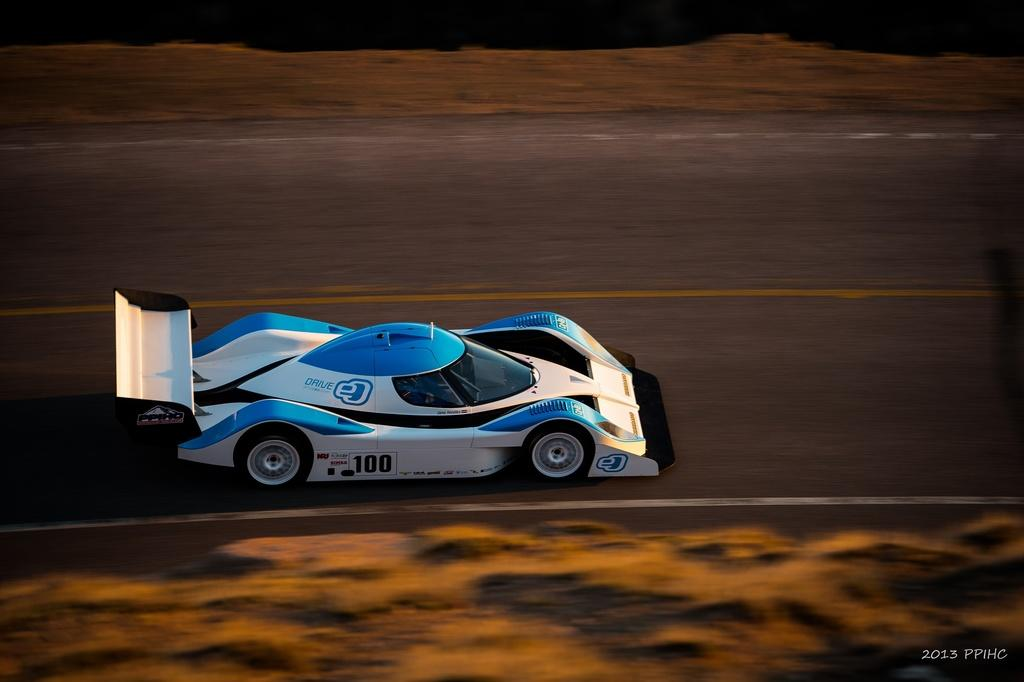What type of image is being described? The image is animated. What can be seen moving on the road in the image? There is a car on the road in the image. What additional information is provided at the bottom of the image? There is text at the bottom of the image. Where is the throne located in the image? There is no throne present in the image. What type of growth can be observed in the image? The image is animated and does not depict any growth. 